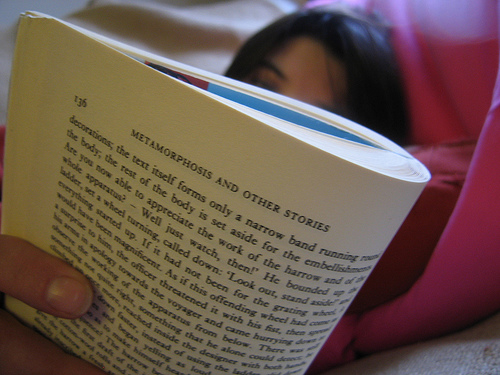<image>
Is the human in front of the book? No. The human is not in front of the book. The spatial positioning shows a different relationship between these objects. 